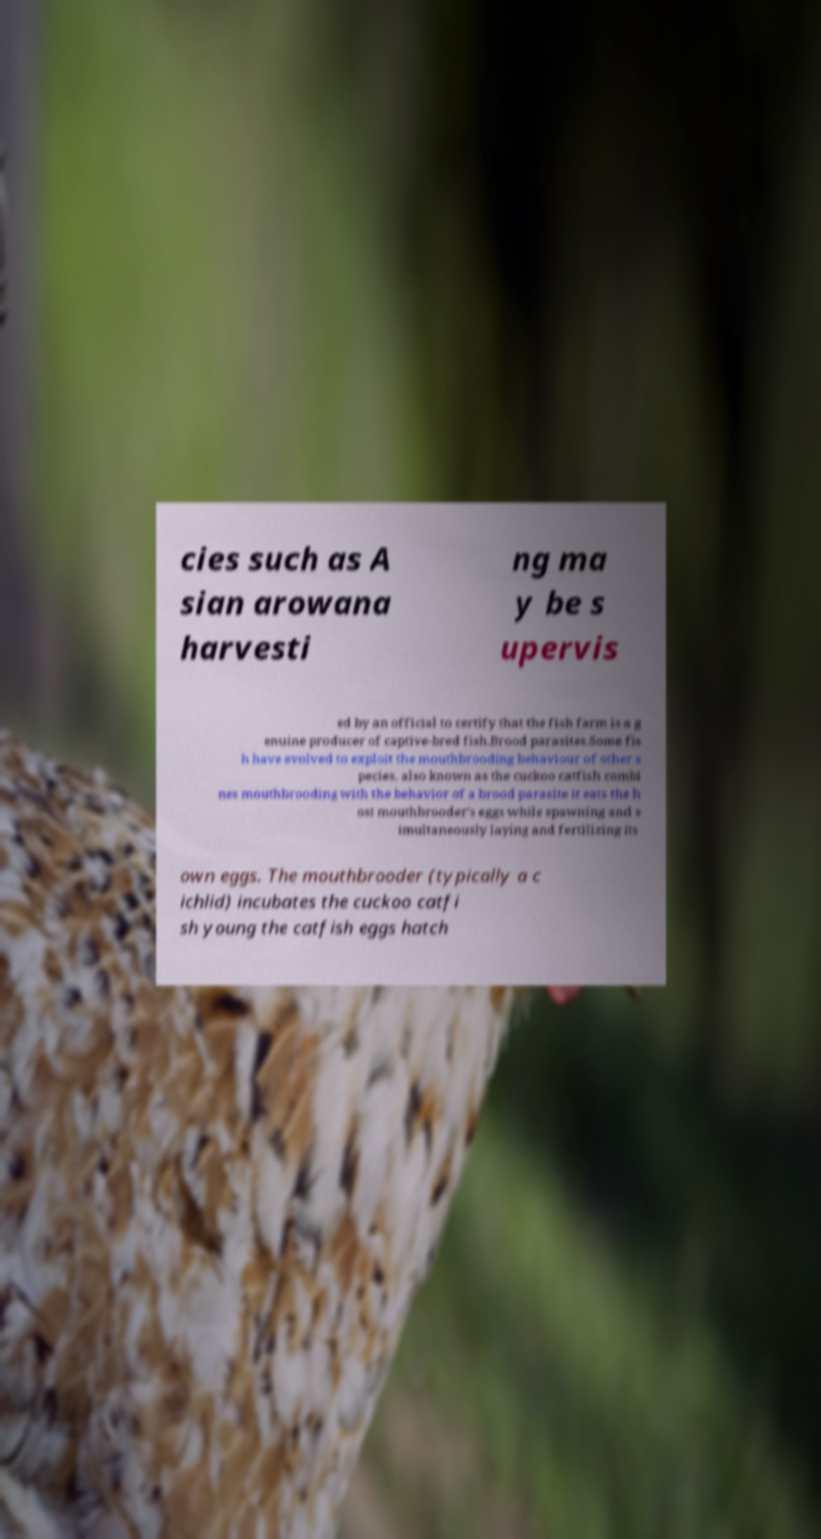For documentation purposes, I need the text within this image transcribed. Could you provide that? cies such as A sian arowana harvesti ng ma y be s upervis ed by an official to certify that the fish farm is a g enuine producer of captive-bred fish.Brood parasites.Some fis h have evolved to exploit the mouthbrooding behaviour of other s pecies. also known as the cuckoo catfish combi nes mouthbrooding with the behavior of a brood parasite it eats the h ost mouthbrooder's eggs while spawning and s imultaneously laying and fertilizing its own eggs. The mouthbrooder (typically a c ichlid) incubates the cuckoo catfi sh young the catfish eggs hatch 